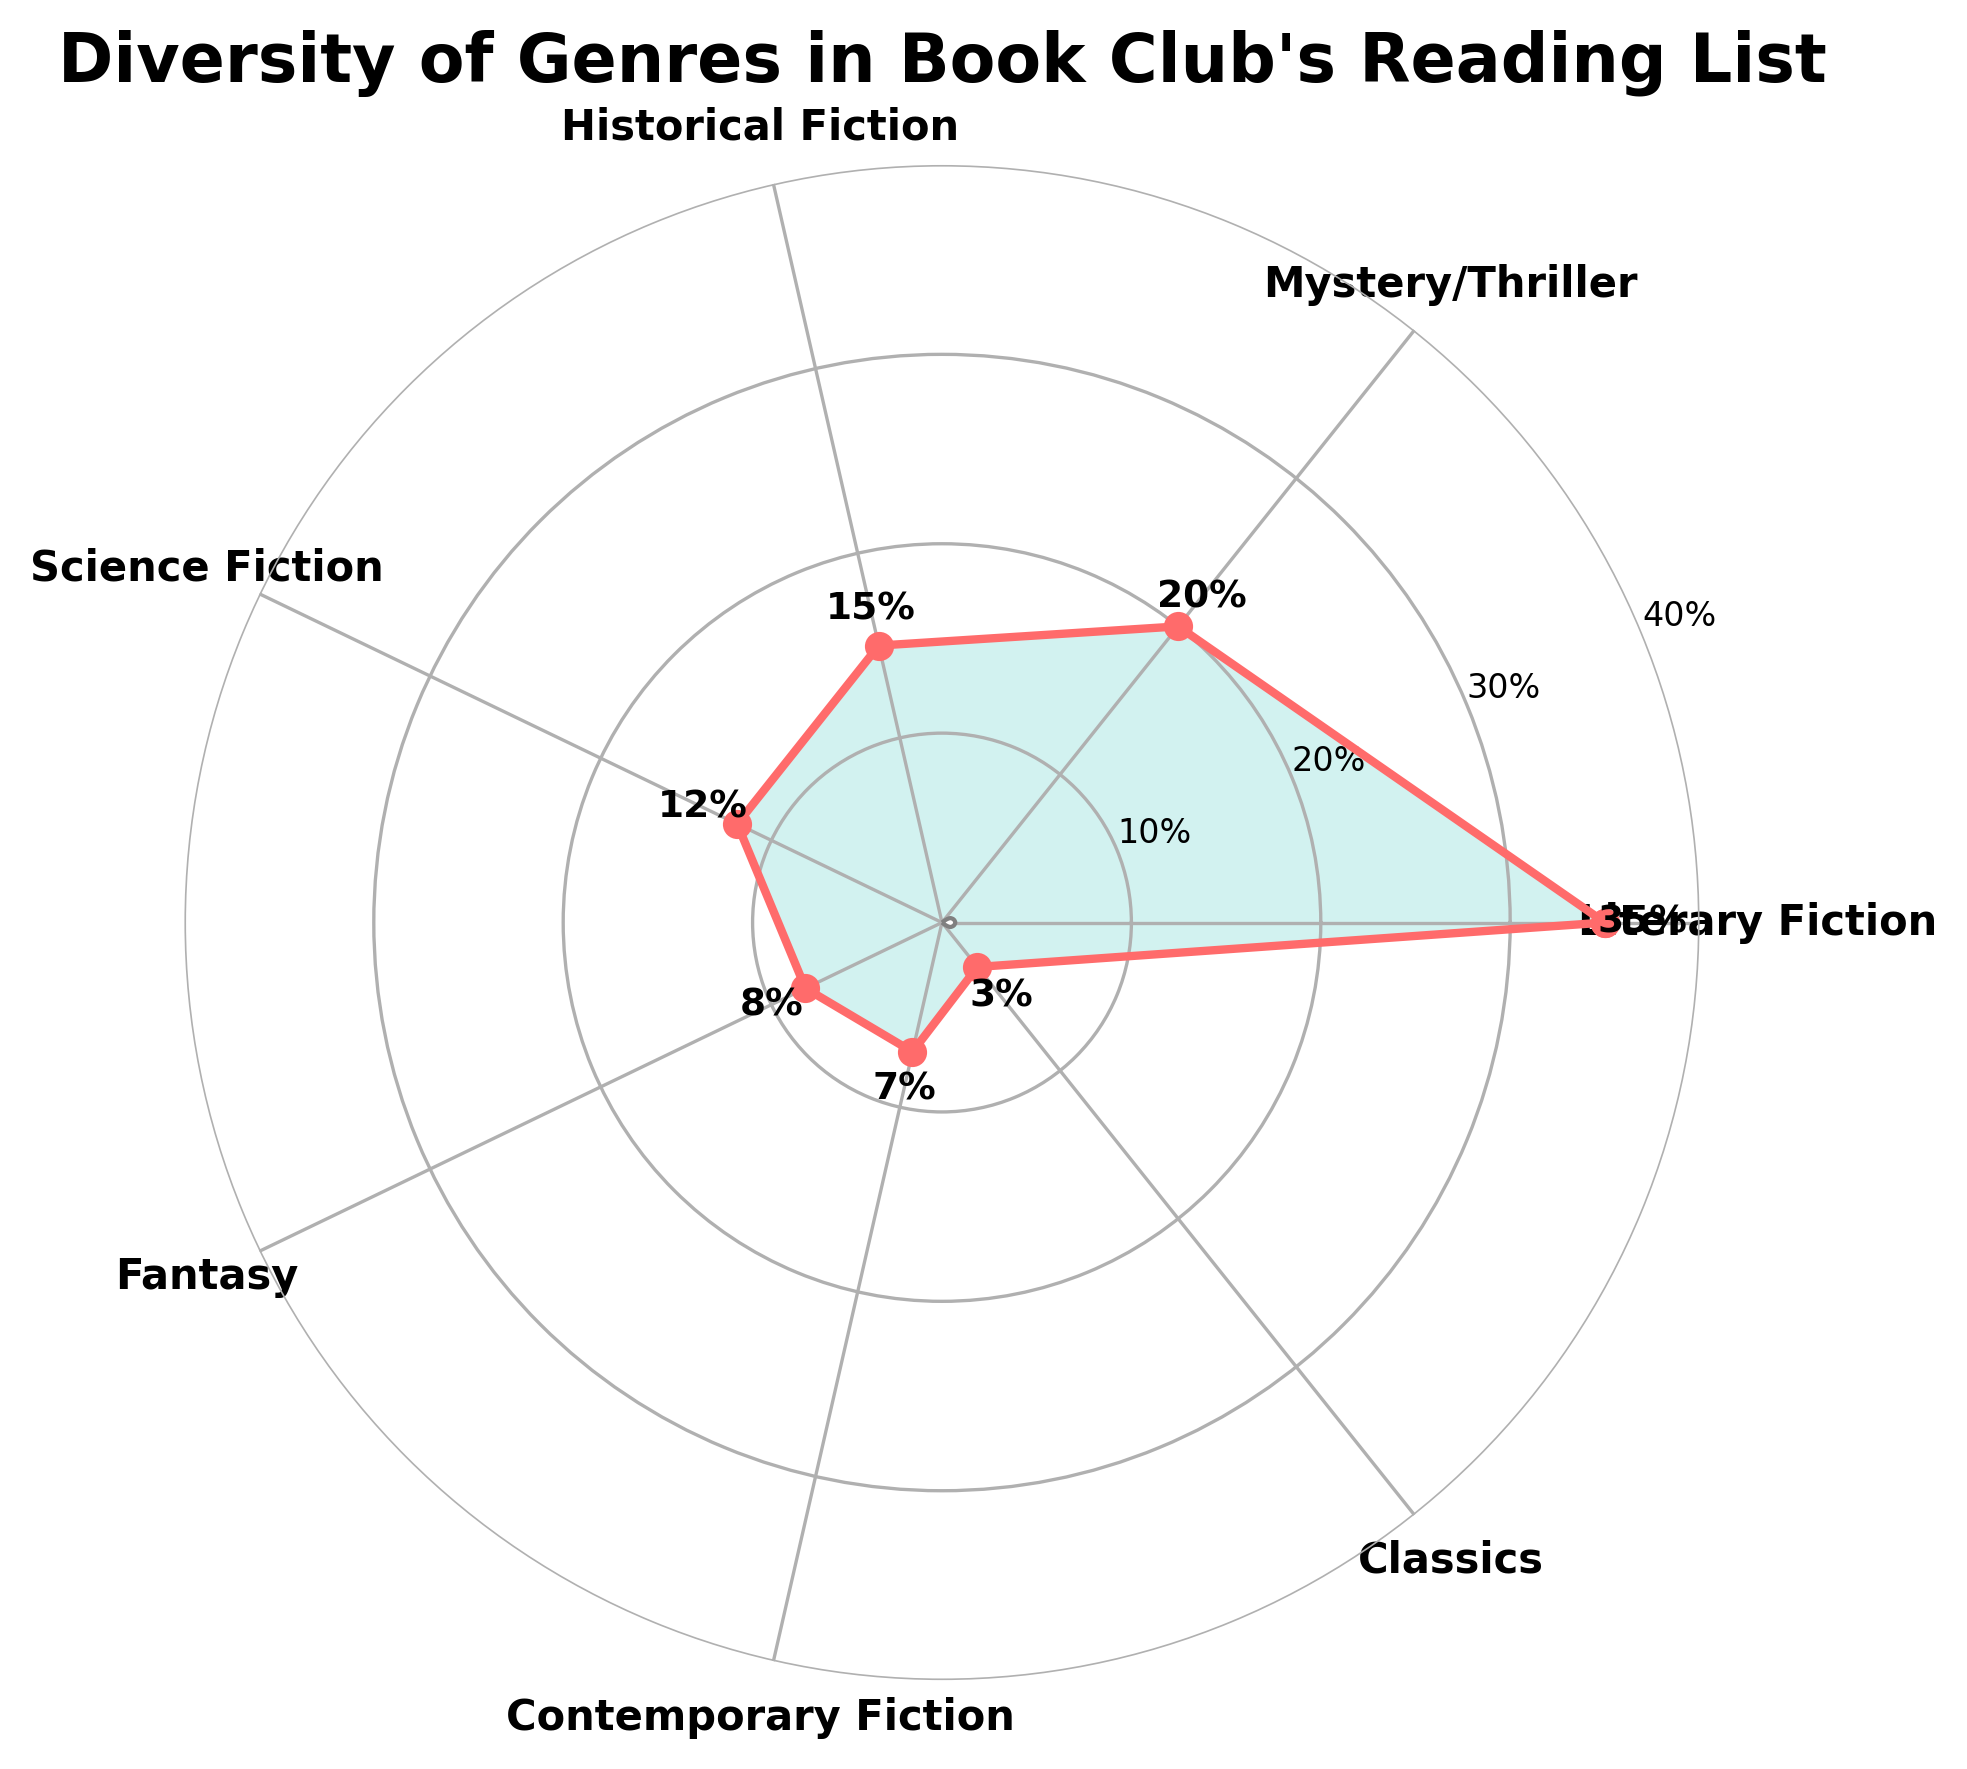What is the title of the figure? The title is at the top of the figure in a large, bold font and reads "Diversity of Genres in Book Club's Reading List".
Answer: Diversity of Genres in Book Club's Reading List Which genre has the highest percentage in the book club's reading list? The genre with the highest percentage has the label with the highest value along the outer edge of the plot. The highest value is 35%, associated with Literary Fiction.
Answer: Literary Fiction How many genres are represented in the club's reading list? The figure has labels distributed evenly around the circular plot. Counting all the labels gives the number of genres. There are 7 genres listed.
Answer: 7 What is the combined percentage of Science Fiction and Fantasy genres? Locate the percentages for Science Fiction and Fantasy, which are 12% and 8% respectively. Add these two percentages together: 12% + 8% = 20%.
Answer: 20% What is the percentage difference between Literary Fiction and Mystery/Thriller genres? Literary Fiction has a percentage of 35%, and Mystery/Thriller has 20%. Subtract the smaller percentage from the larger one: 35% - 20% = 15%.
Answer: 15% Which genre has the smallest percentage in the book club’s reading list? The genre with the smallest percentage is the one with the lowest value label. The smallest value is 3%, associated with Classics.
Answer: Classics Which genres are less than 10% of the reading list? Look for all genres with percentages less than 10%. These are Fantasy (8%), Contemporary Fiction (7%), and Classics (3%).
Answer: Fantasy, Contemporary Fiction, Classics Is the percentage of Contemporary Fiction greater than or equal to that of Science Fiction? Compare the percentages: Contemporary Fiction is 7%, and Science Fiction is 12%. 7% is less than 12%.
Answer: No What is the median percentage value among all the genres? List the percentages in ascending order: 3%, 7%, 8%, 12%, 15%, 20%, 35%. With 7 values, the median is the middle value, which is 12%.
Answer: 12% By how much does the percentage of Historical Fiction exceed that of Classics? Historical Fiction has 15%, and Classics have 3%. Subtract the smaller percentage from the larger: 15% - 3% = 12%.
Answer: 12% 